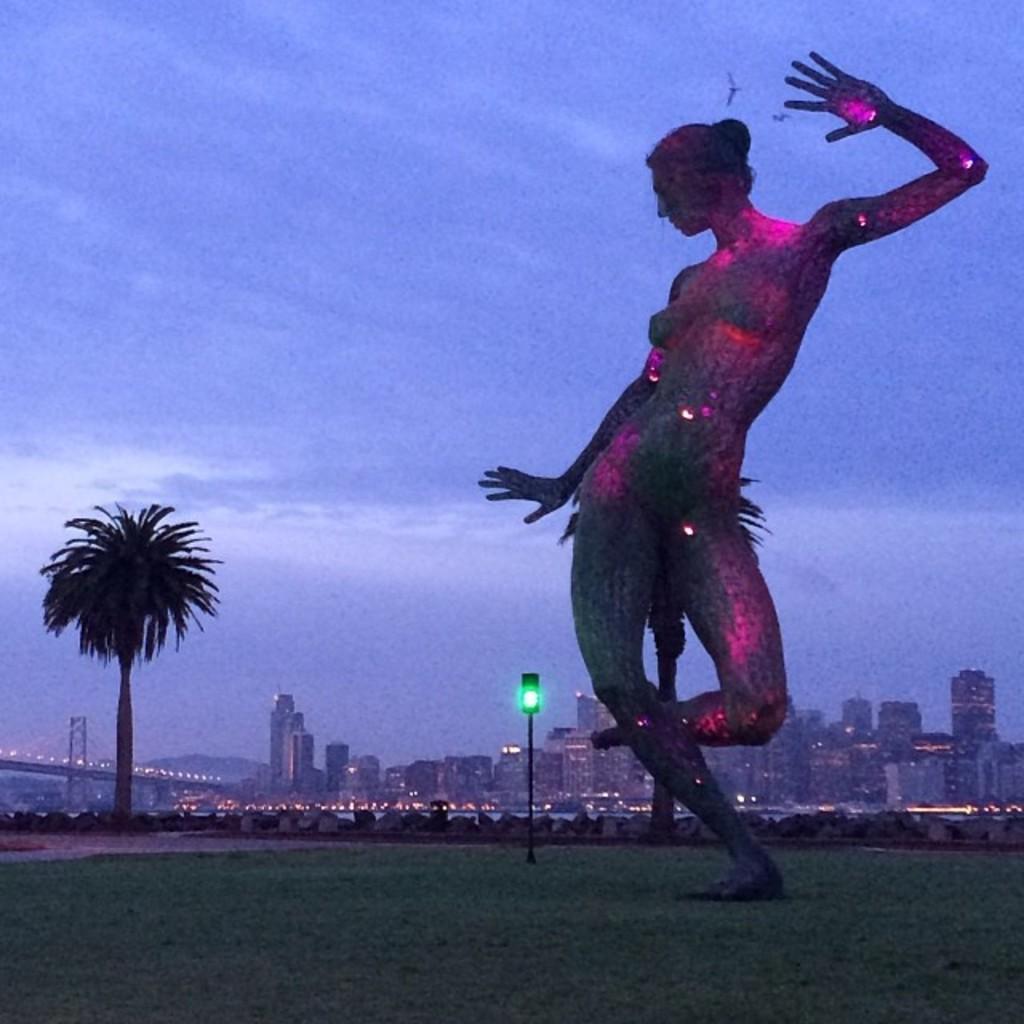How would you summarize this image in a sentence or two? In this image there is a statue on the grass surface, behind the statue there is a traffic light and a tree, in the background of the image there are buildings and a bridge. 